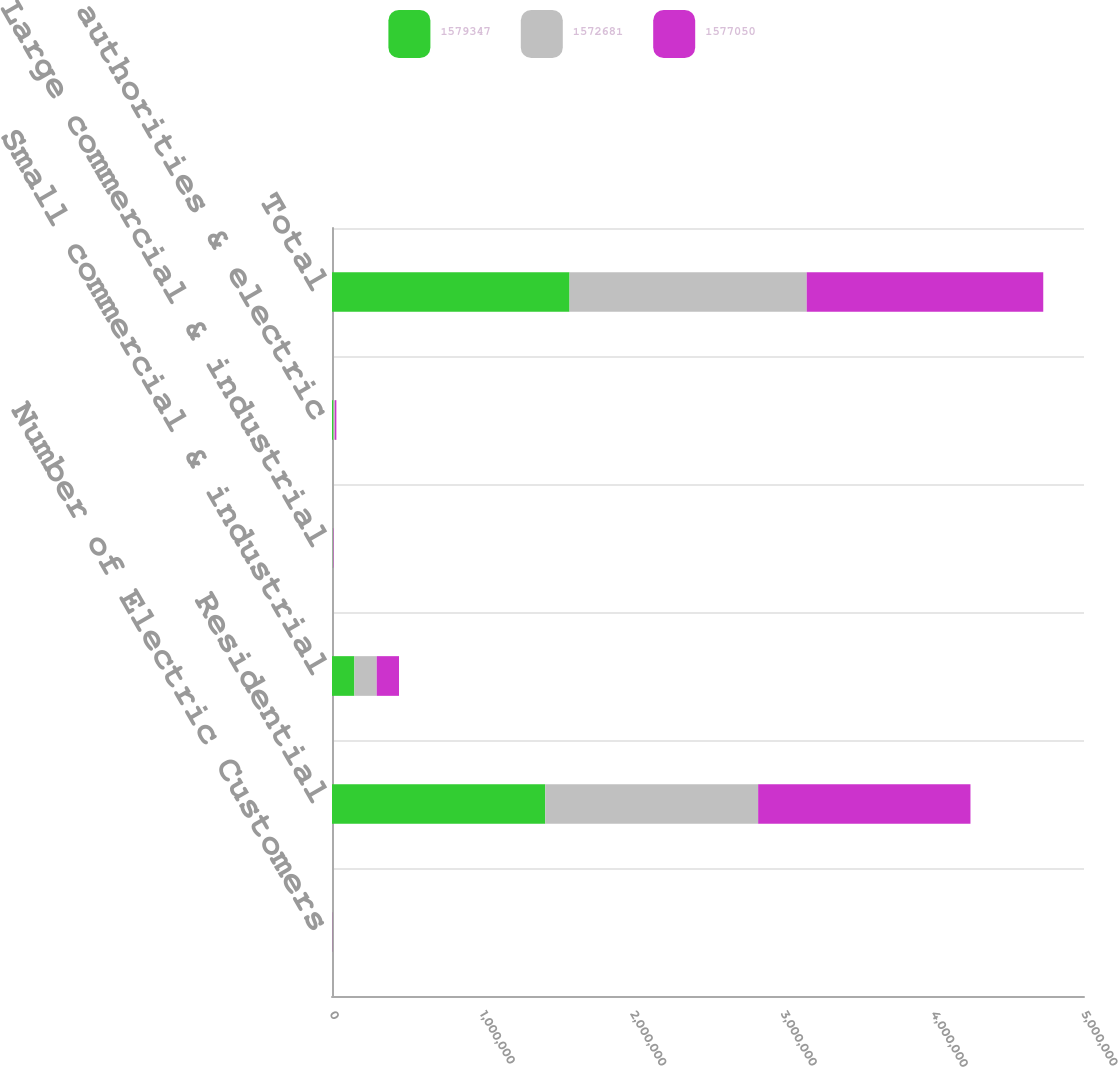Convert chart to OTSL. <chart><loc_0><loc_0><loc_500><loc_500><stacked_bar_chart><ecel><fcel>Number of Electric Customers<fcel>Residential<fcel>Small commercial & industrial<fcel>Large commercial & industrial<fcel>Public authorities & electric<fcel>Total<nl><fcel>1.57935e+06<fcel>2012<fcel>1.41777e+06<fcel>148803<fcel>3111<fcel>9660<fcel>1.57935e+06<nl><fcel>1.57268e+06<fcel>2011<fcel>1.41568e+06<fcel>148570<fcel>3110<fcel>9689<fcel>1.57705e+06<nl><fcel>1.57705e+06<fcel>2010<fcel>1.41164e+06<fcel>148297<fcel>3071<fcel>9670<fcel>1.57268e+06<nl></chart> 